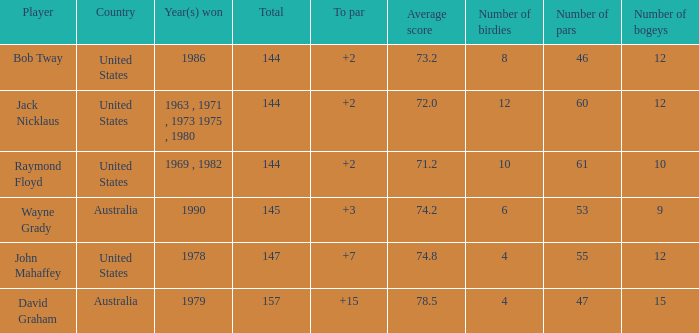How many strokes off par was the winner in 1978? 7.0. 